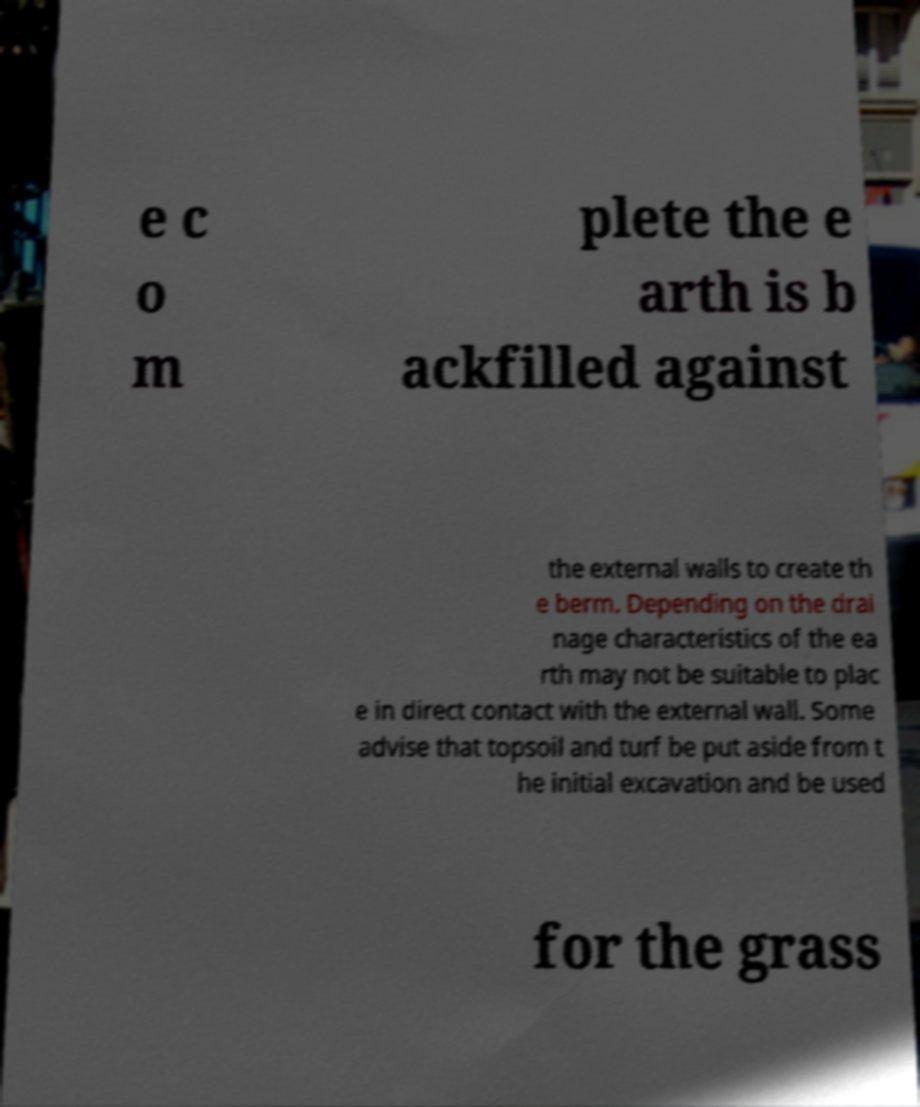What messages or text are displayed in this image? I need them in a readable, typed format. e c o m plete the e arth is b ackfilled against the external walls to create th e berm. Depending on the drai nage characteristics of the ea rth may not be suitable to plac e in direct contact with the external wall. Some advise that topsoil and turf be put aside from t he initial excavation and be used for the grass 